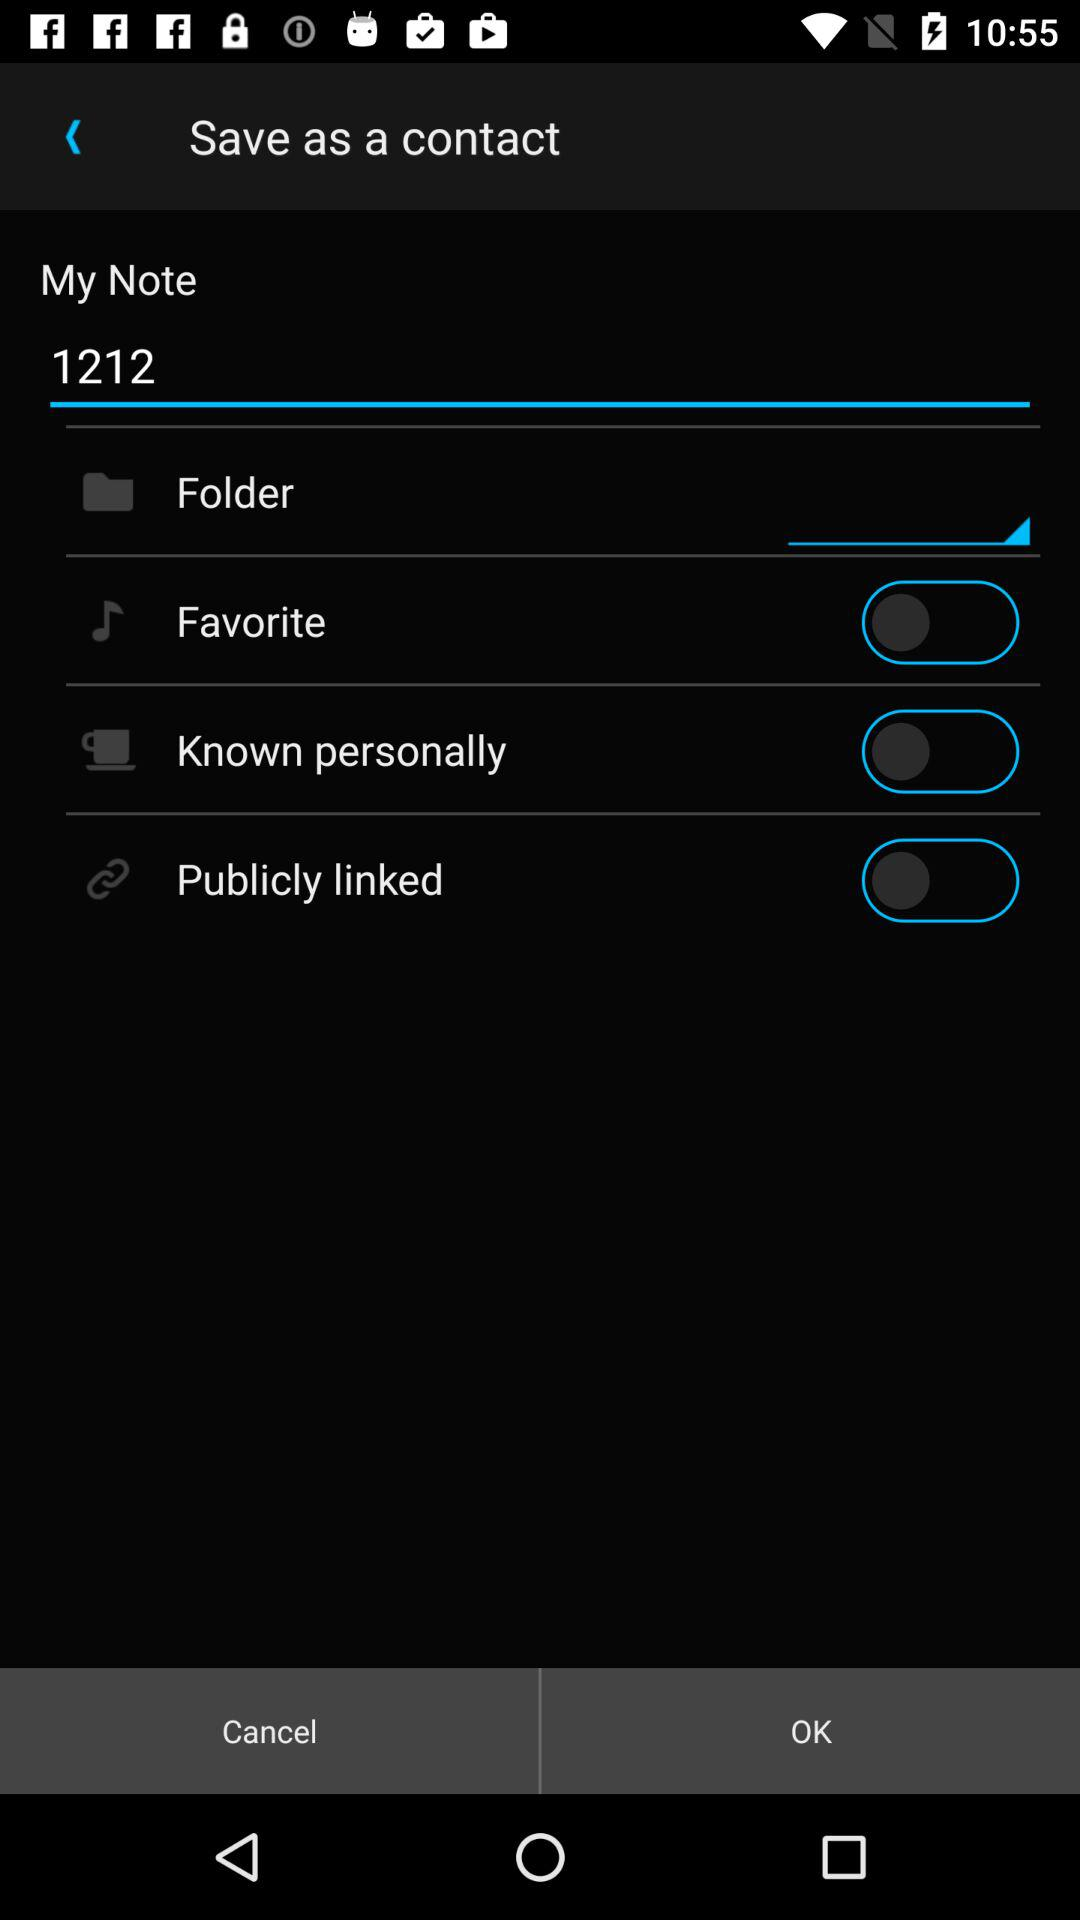What is the current status of "Publicly linked"? The status is "off". 